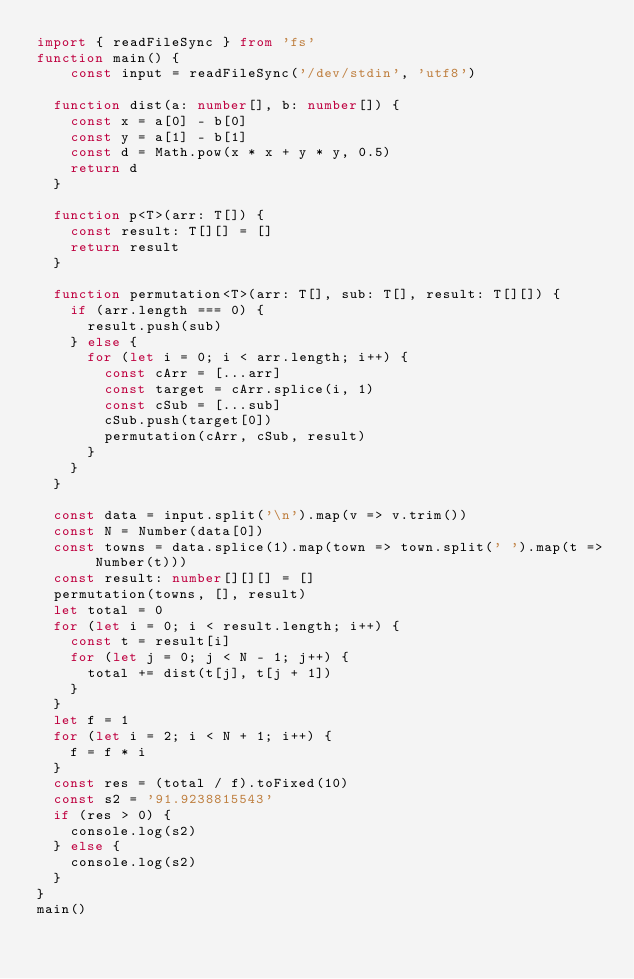<code> <loc_0><loc_0><loc_500><loc_500><_TypeScript_>import { readFileSync } from 'fs'
function main() {
	const input = readFileSync('/dev/stdin', 'utf8')

  function dist(a: number[], b: number[]) {
    const x = a[0] - b[0]
    const y = a[1] - b[1]
    const d = Math.pow(x * x + y * y, 0.5)
    return d
  }

  function p<T>(arr: T[]) {
    const result: T[][] = []
    return result
  }

  function permutation<T>(arr: T[], sub: T[], result: T[][]) {
    if (arr.length === 0) {
      result.push(sub)
    } else {
      for (let i = 0; i < arr.length; i++) {
        const cArr = [...arr]
        const target = cArr.splice(i, 1)
        const cSub = [...sub]
        cSub.push(target[0])
        permutation(cArr, cSub, result)        
      }
    }
  }

  const data = input.split('\n').map(v => v.trim())
  const N = Number(data[0])
  const towns = data.splice(1).map(town => town.split(' ').map(t => Number(t)))
  const result: number[][][] = []
  permutation(towns, [], result)
  let total = 0
  for (let i = 0; i < result.length; i++) {
    const t = result[i]
    for (let j = 0; j < N - 1; j++) {
      total += dist(t[j], t[j + 1])      
    }
  }
  let f = 1
  for (let i = 2; i < N + 1; i++) {
    f = f * i
  }
  const res = (total / f).toFixed(10)
  const s2 = '91.9238815543'
  if (res > 0) {
    console.log(s2)
  } else {
    console.log(s2)
  }
}
main()
</code> 